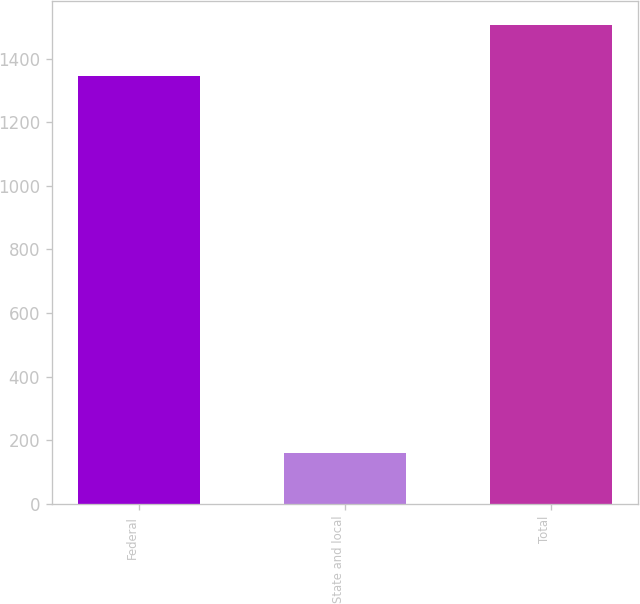Convert chart to OTSL. <chart><loc_0><loc_0><loc_500><loc_500><bar_chart><fcel>Federal<fcel>State and local<fcel>Total<nl><fcel>1344<fcel>161<fcel>1506<nl></chart> 